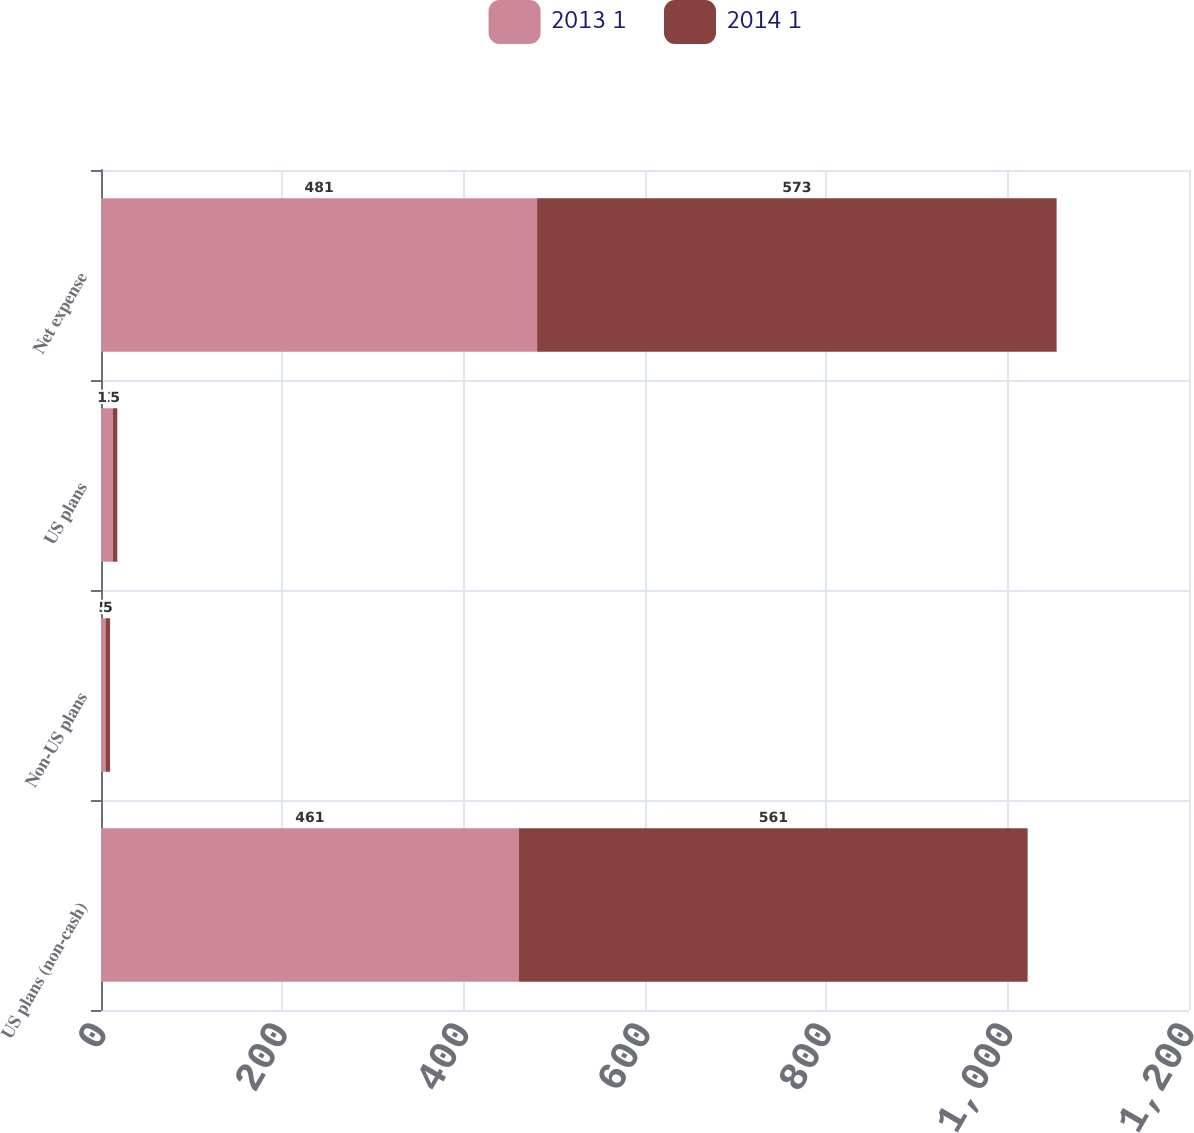Convert chart to OTSL. <chart><loc_0><loc_0><loc_500><loc_500><stacked_bar_chart><ecel><fcel>US plans (non-cash)<fcel>Non-US plans<fcel>US plans<fcel>Net expense<nl><fcel>2013 1<fcel>461<fcel>5<fcel>13<fcel>481<nl><fcel>2014 1<fcel>561<fcel>5<fcel>5<fcel>573<nl></chart> 